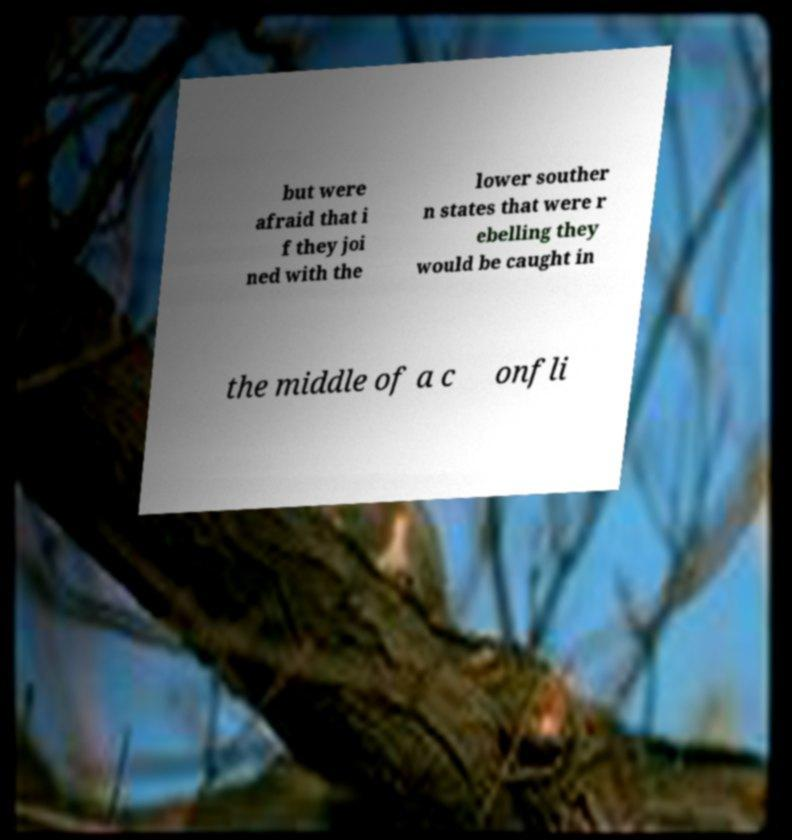Please read and relay the text visible in this image. What does it say? but were afraid that i f they joi ned with the lower souther n states that were r ebelling they would be caught in the middle of a c onfli 